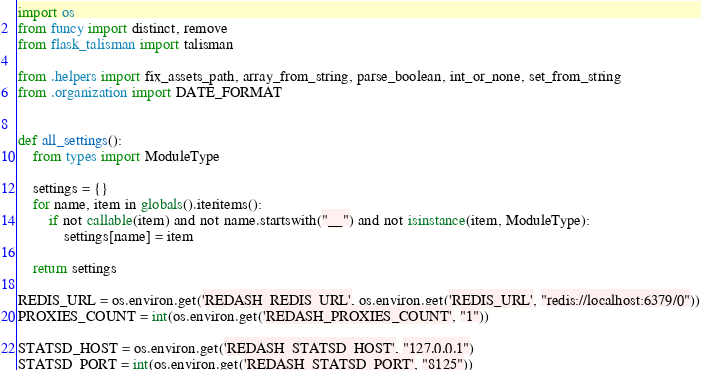<code> <loc_0><loc_0><loc_500><loc_500><_Python_>import os
from funcy import distinct, remove
from flask_talisman import talisman

from .helpers import fix_assets_path, array_from_string, parse_boolean, int_or_none, set_from_string
from .organization import DATE_FORMAT


def all_settings():
    from types import ModuleType

    settings = {}
    for name, item in globals().iteritems():
        if not callable(item) and not name.startswith("__") and not isinstance(item, ModuleType):
            settings[name] = item

    return settings

REDIS_URL = os.environ.get('REDASH_REDIS_URL', os.environ.get('REDIS_URL', "redis://localhost:6379/0"))
PROXIES_COUNT = int(os.environ.get('REDASH_PROXIES_COUNT', "1"))

STATSD_HOST = os.environ.get('REDASH_STATSD_HOST', "127.0.0.1")
STATSD_PORT = int(os.environ.get('REDASH_STATSD_PORT', "8125"))</code> 